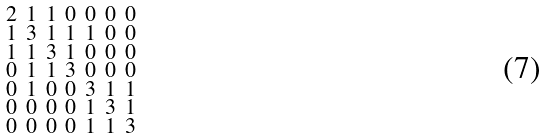<formula> <loc_0><loc_0><loc_500><loc_500>\begin{smallmatrix} 2 & 1 & 1 & 0 & 0 & 0 & 0 \\ 1 & 3 & 1 & 1 & 1 & 0 & 0 \\ 1 & 1 & 3 & 1 & 0 & 0 & 0 \\ 0 & 1 & 1 & 3 & 0 & 0 & 0 \\ 0 & 1 & 0 & 0 & 3 & 1 & 1 \\ 0 & 0 & 0 & 0 & 1 & 3 & 1 \\ 0 & 0 & 0 & 0 & 1 & 1 & 3 \end{smallmatrix}</formula> 